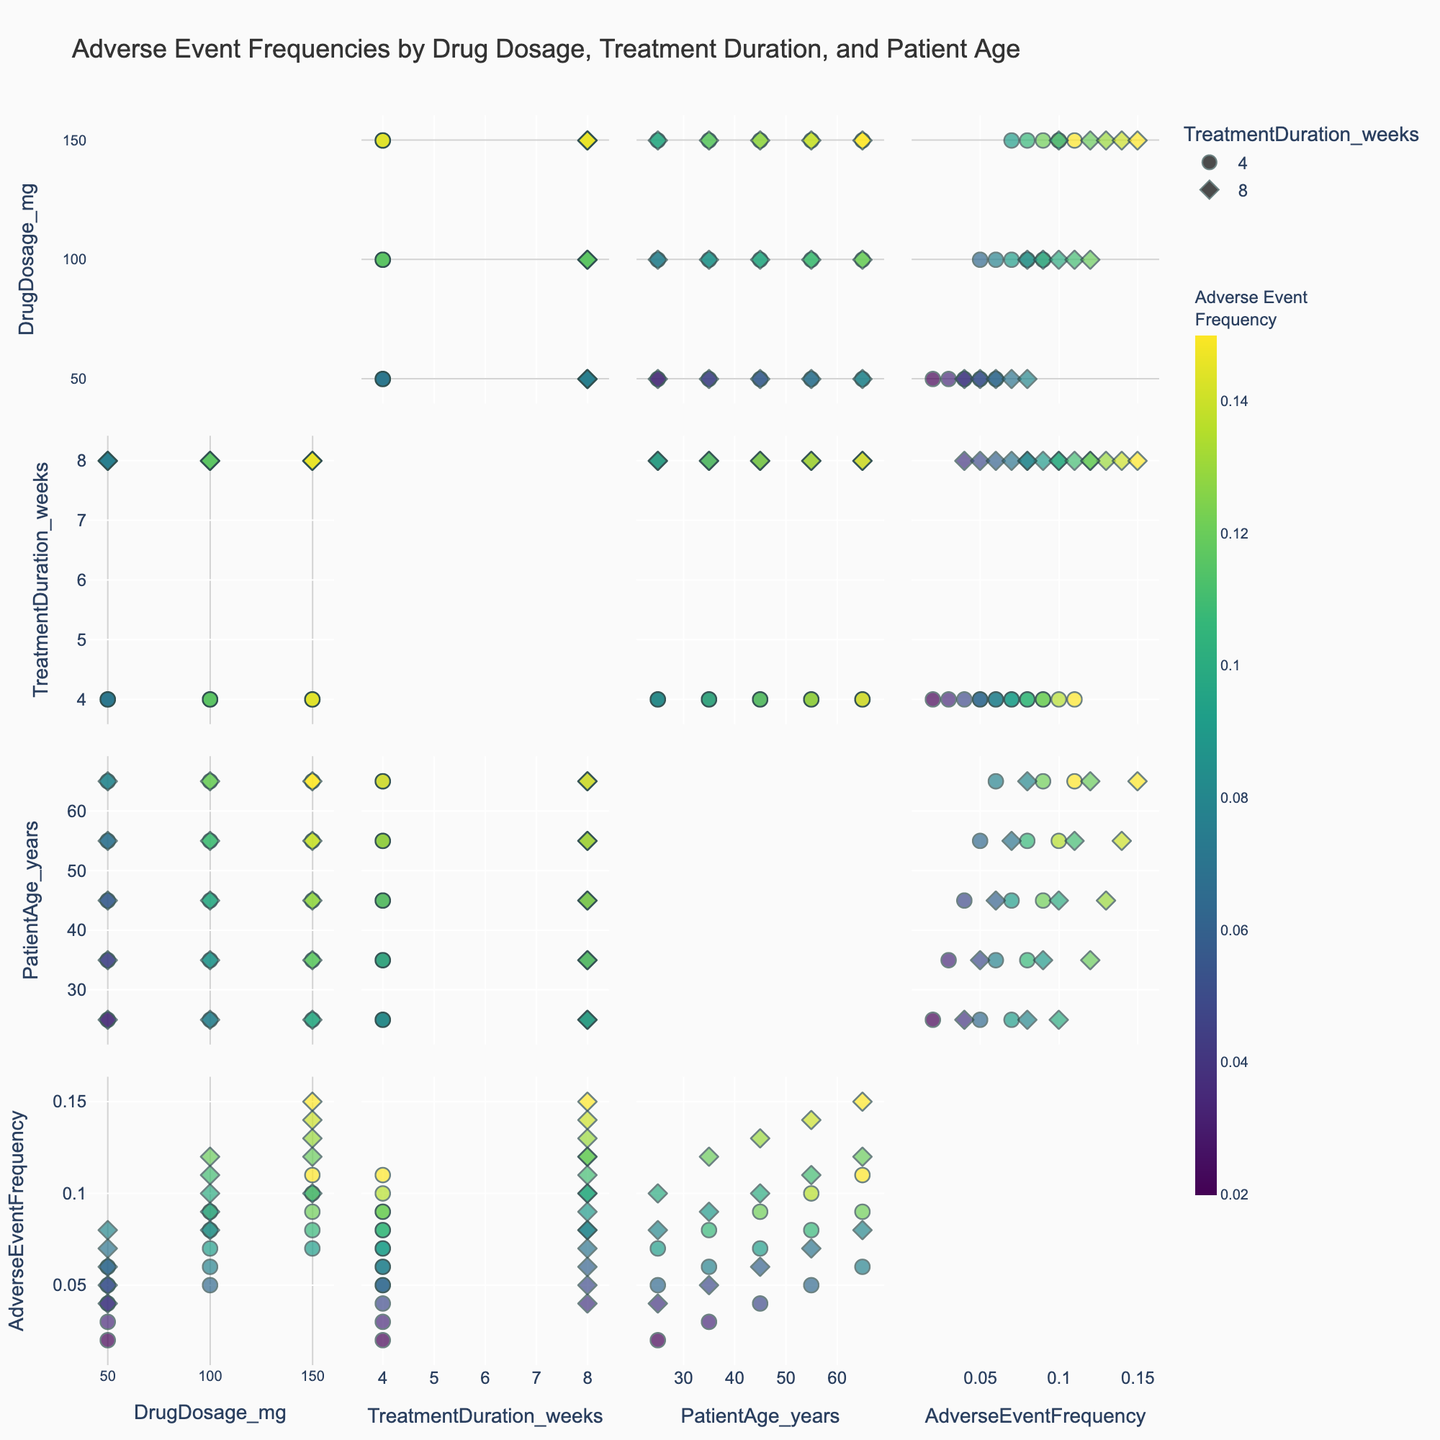What is the title of the SPLOM figure? The title is generally found at the top of the figure. In this case, it reads "Adverse Event Frequencies by Drug Dosage, Treatment Duration, and Patient Age".
Answer: Adverse Event Frequencies by Drug Dosage, Treatment Duration, and Patient Age How many dimensions are being compared in the SPLOM figure? The SPLOM figure compares the dimensions shown along both axes. In this plot, the dimensions are DrugDosage_mg, TreatmentDuration_weeks, PatientAge_years, and AdverseEventFrequency.
Answer: 4 Which dimension is used to color the points in the SPLOM? The data points are colored according to AdverseEventFrequency as indicated by the color bar with the title 'Adverse Event Frequency' on the right side of the figure.
Answer: AdverseEventFrequency Does an increase in DrugDosage_mg generally correlate with an increase in AdverseEventFrequency across all age groups? To determine this, observe the scatter plots comparing DrugDosage_mg and AdverseEventFrequency. Generally, as DrugDosage_mg increases, AdverseEventFrequency also increases across all age groups.
Answer: Yes Which age group shows the highest AdverseEventFrequency at the highest DrugDosage_mg? The highest DrugDosage_mg is 150 mg. Checking the data points associated with this dosage across various age groups, the age group 65 years shows the highest AdverseEventFrequency.
Answer: 65 years What is the mean DrugDosage_mg for TreatmentDuration_weeks of 8 weeks? To find this, consider all the points with TreatmentDuration_weeks of 8 weeks and calculate the average DrugDosage_mg. The eligible values are 50, 100, and 150 mg. The mean is (50 + 100 + 150)/3.
Answer: 100 mg How does AdverseEventFrequency change with increasing TreatmentDuration_weeks for patients aged 35 years? Observing the scatter plots comparing TreatmentDuration_weeks and AdverseEventFrequency for the age group 35 years, as TreatmentDuration_weeks increases from 4 to 8 weeks, AdverseEventFrequency increases.
Answer: Increases What is the range of AdverseEventFrequency for the smallest and largest DrugDosage_mg? The smallest DrugDosage_mg is 50 mg, and the largest is 150 mg. Check the scatter plots to find the range of AdverseEventFrequency for both: For 50 mg, the range is [0.02, 0.08], and for 150 mg, the range is [0.07, 0.15].
Answer: 0.02 to 0.15 Do different TreatmentDuration_weeks have distinct symbols in the SPLOM? By examining the scatter plots carefully, one can see the different symbols representing different TreatmentDuration_weeks. This visual distinction is clearly stated in the legend.
Answer: Yes Which combination of DrugDosage_mg and TreatmentDuration_weeks results in the highest AdverseEventFrequency among 45-year-old patients? For 45-year-old patients, consider the scatter plots for all combinations. The highest AdverseEventFrequency is achieved with a DrugDosage_mg of 150 mg and TreatmentDuration_weeks of 8 weeks.
Answer: 150 mg and 8 weeks 